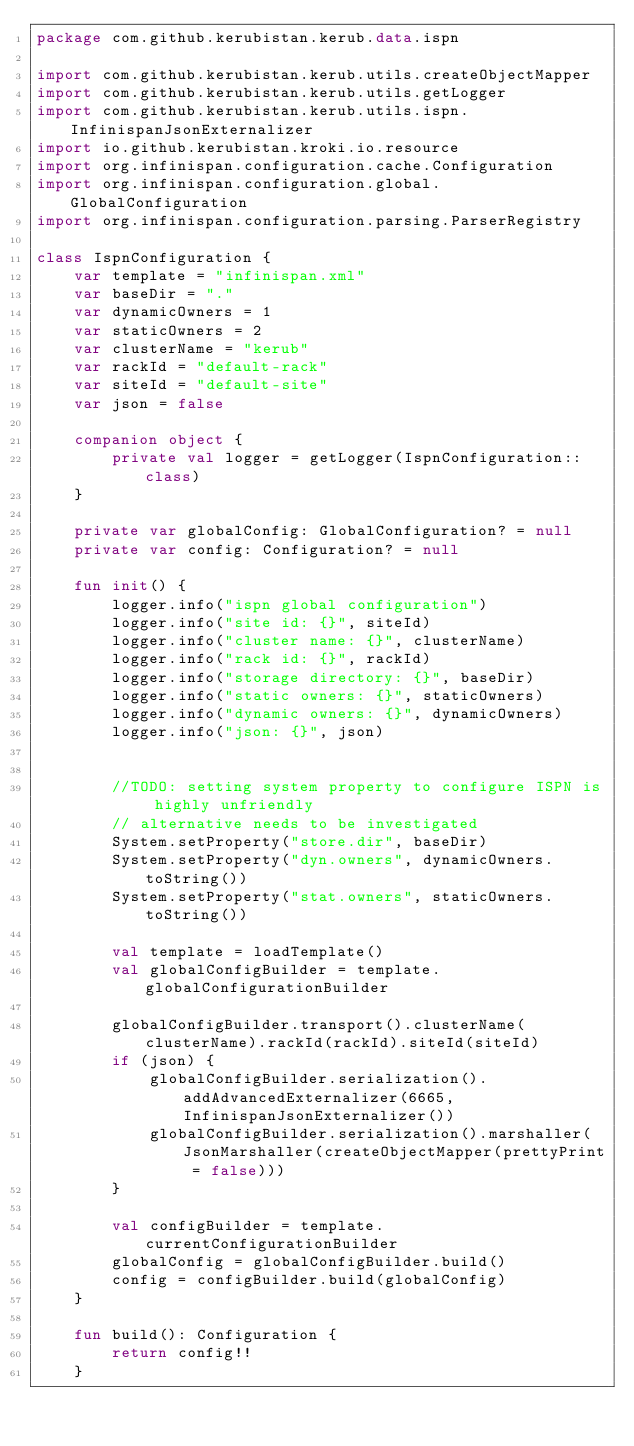Convert code to text. <code><loc_0><loc_0><loc_500><loc_500><_Kotlin_>package com.github.kerubistan.kerub.data.ispn

import com.github.kerubistan.kerub.utils.createObjectMapper
import com.github.kerubistan.kerub.utils.getLogger
import com.github.kerubistan.kerub.utils.ispn.InfinispanJsonExternalizer
import io.github.kerubistan.kroki.io.resource
import org.infinispan.configuration.cache.Configuration
import org.infinispan.configuration.global.GlobalConfiguration
import org.infinispan.configuration.parsing.ParserRegistry

class IspnConfiguration {
	var template = "infinispan.xml"
	var baseDir = "."
	var dynamicOwners = 1
	var staticOwners = 2
	var clusterName = "kerub"
	var rackId = "default-rack"
	var siteId = "default-site"
	var json = false

	companion object {
		private val logger = getLogger(IspnConfiguration::class)
	}

	private var globalConfig: GlobalConfiguration? = null
	private var config: Configuration? = null

	fun init() {
		logger.info("ispn global configuration")
		logger.info("site id: {}", siteId)
		logger.info("cluster name: {}", clusterName)
		logger.info("rack id: {}", rackId)
		logger.info("storage directory: {}", baseDir)
		logger.info("static owners: {}", staticOwners)
		logger.info("dynamic owners: {}", dynamicOwners)
		logger.info("json: {}", json)


		//TODO: setting system property to configure ISPN is highly unfriendly
		// alternative needs to be investigated
		System.setProperty("store.dir", baseDir)
		System.setProperty("dyn.owners", dynamicOwners.toString())
		System.setProperty("stat.owners", staticOwners.toString())

		val template = loadTemplate()
		val globalConfigBuilder = template.globalConfigurationBuilder

		globalConfigBuilder.transport().clusterName(clusterName).rackId(rackId).siteId(siteId)
		if (json) {
			globalConfigBuilder.serialization().addAdvancedExternalizer(6665, InfinispanJsonExternalizer())
			globalConfigBuilder.serialization().marshaller(JsonMarshaller(createObjectMapper(prettyPrint = false)))
		}

		val configBuilder = template.currentConfigurationBuilder
		globalConfig = globalConfigBuilder.build()
		config = configBuilder.build(globalConfig)
	}

	fun build(): Configuration {
		return config!!
	}
</code> 